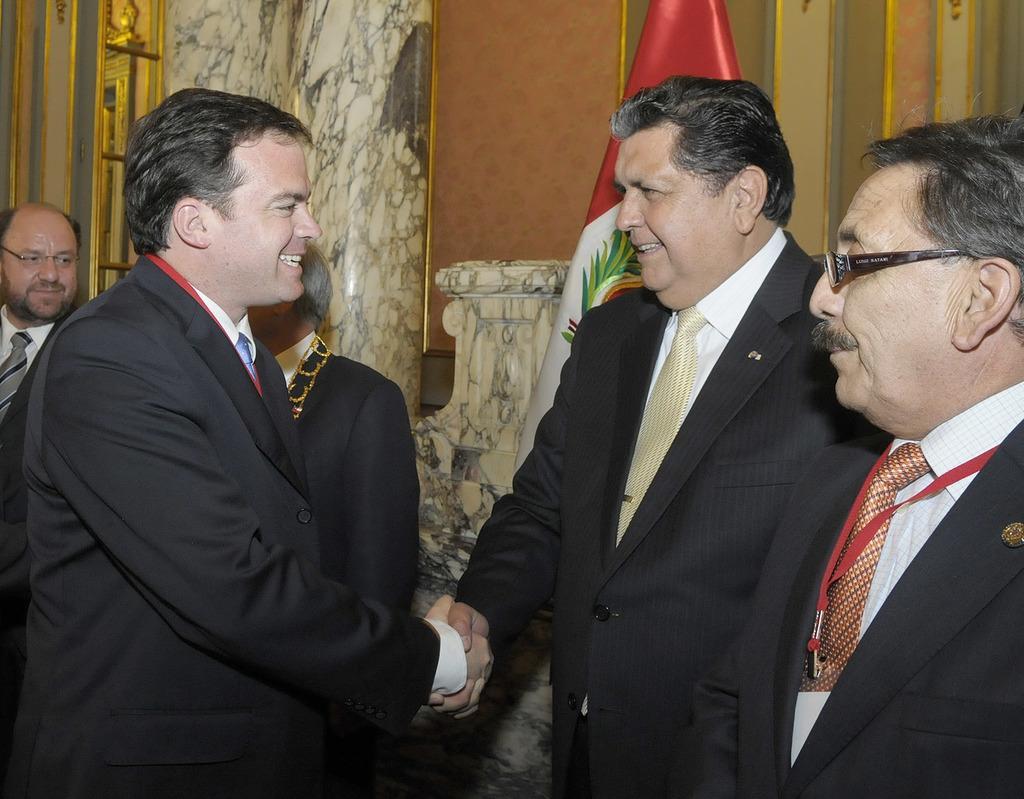Please provide a concise description of this image. This picture shows few men standing couple of them wore spectacles on their faces and we see couple of men shaking their hands and we see a flag on the back all of them wore coats and ties. 